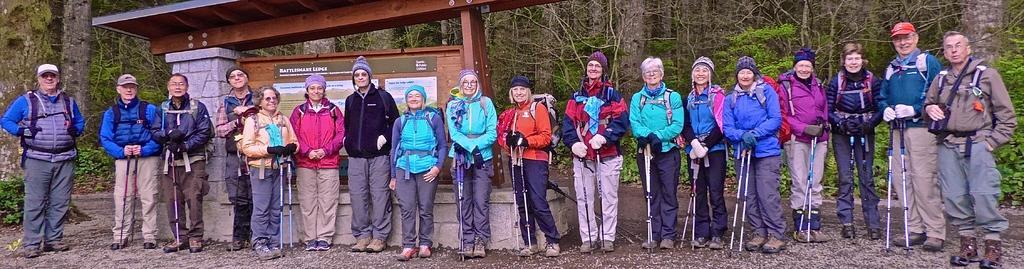Describe this image in one or two sentences. In this image we can see a group of people standing on the ground. They are wearing the jackets and here we can see the caps on their heads. They are holding the ski poles in their hands and here we can see the smile on their faces. Here we can see the wooden billboard. In the background, we can see the trees. 